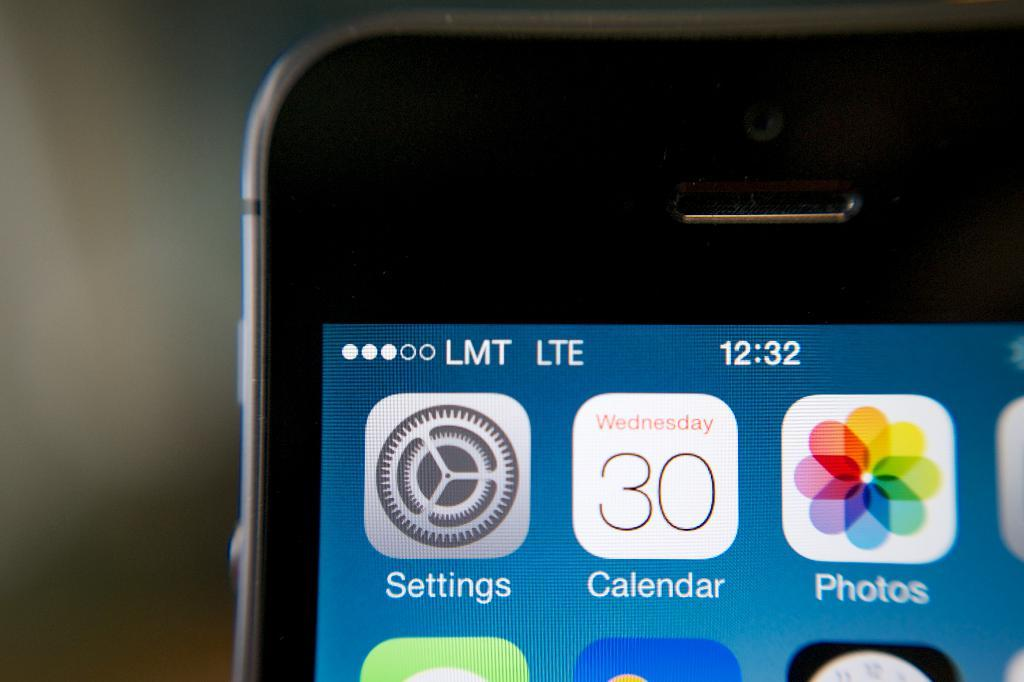<image>
Offer a succinct explanation of the picture presented. The upper left corner of a LMT phone shows the Settings,Calendar, and Photos applications. 